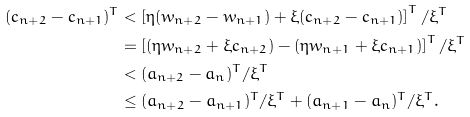Convert formula to latex. <formula><loc_0><loc_0><loc_500><loc_500>( c _ { n + 2 } - c _ { n + 1 } ) ^ { T } & < \left [ \eta ( w _ { n + 2 } - w _ { n + 1 } ) + \xi ( c _ { n + 2 } - c _ { n + 1 } ) \right ] ^ { T } / \xi ^ { T } \\ & = \left [ ( \eta w _ { n + 2 } + \xi c _ { n + 2 } ) - ( \eta w _ { n + 1 } + \xi c _ { n + 1 } ) \right ] ^ { T } / \xi ^ { T } \\ & < ( a _ { n + 2 } - a _ { n } ) ^ { T } / \xi ^ { T } \\ & \leq ( a _ { n + 2 } - a _ { n + 1 } ) ^ { T } / \xi ^ { T } + ( a _ { n + 1 } - a _ { n } ) ^ { T } / \xi ^ { T } .</formula> 